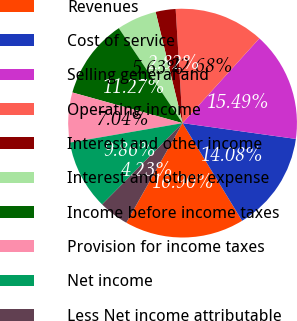Convert chart to OTSL. <chart><loc_0><loc_0><loc_500><loc_500><pie_chart><fcel>Revenues<fcel>Cost of service<fcel>Selling general and<fcel>Operating income<fcel>Interest and other income<fcel>Interest and other expense<fcel>Income before income taxes<fcel>Provision for income taxes<fcel>Net income<fcel>Less Net income attributable<nl><fcel>16.9%<fcel>14.08%<fcel>15.49%<fcel>12.68%<fcel>2.82%<fcel>5.63%<fcel>11.27%<fcel>7.04%<fcel>9.86%<fcel>4.23%<nl></chart> 